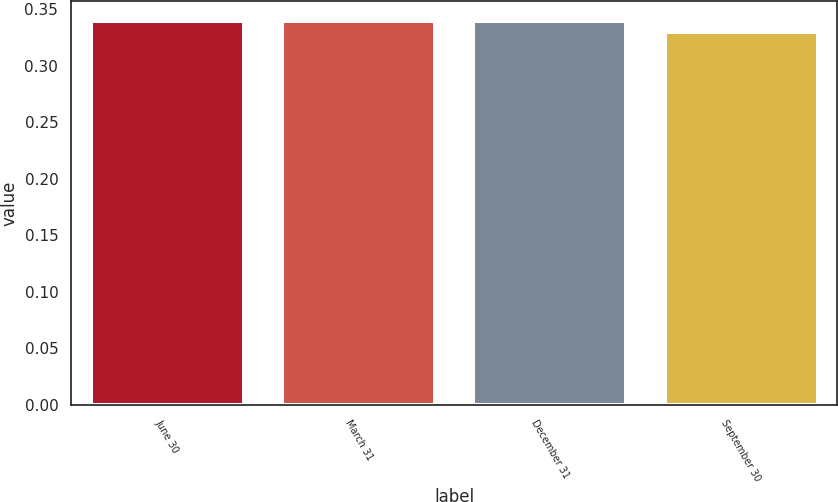Convert chart. <chart><loc_0><loc_0><loc_500><loc_500><bar_chart><fcel>June 30<fcel>March 31<fcel>December 31<fcel>September 30<nl><fcel>0.34<fcel>0.34<fcel>0.34<fcel>0.33<nl></chart> 